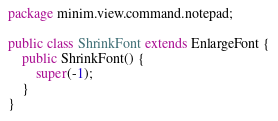Convert code to text. <code><loc_0><loc_0><loc_500><loc_500><_Java_>package minim.view.command.notepad;

public class ShrinkFont extends EnlargeFont {
	public ShrinkFont() {
		super(-1);
	}
}
</code> 